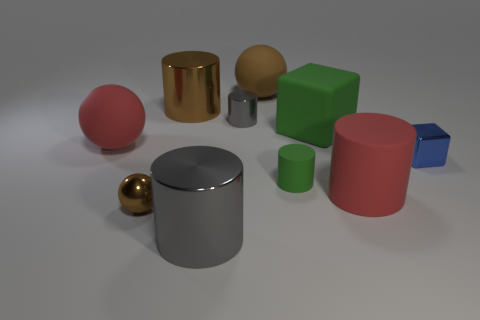What number of objects are either red objects or yellow shiny blocks?
Offer a very short reply. 2. How many other things are the same shape as the brown rubber object?
Your response must be concise. 2. Is the material of the red thing that is left of the brown shiny cylinder the same as the cylinder in front of the tiny brown thing?
Your response must be concise. No. What shape is the tiny thing that is both left of the large rubber cylinder and on the right side of the brown matte thing?
Your answer should be compact. Cylinder. Are there any other things that are the same material as the small green cylinder?
Give a very brief answer. Yes. There is a big cylinder that is both in front of the small shiny cylinder and behind the tiny shiny sphere; what is it made of?
Give a very brief answer. Rubber. What shape is the blue object that is the same material as the tiny brown ball?
Offer a terse response. Cube. Is there anything else that is the same color as the metallic ball?
Keep it short and to the point. Yes. Is the number of big brown cylinders in front of the small gray metal cylinder greater than the number of spheres?
Offer a terse response. No. What is the material of the tiny block?
Make the answer very short. Metal. 